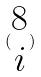Convert formula to latex. <formula><loc_0><loc_0><loc_500><loc_500>( \begin{matrix} 8 \\ i \end{matrix} )</formula> 